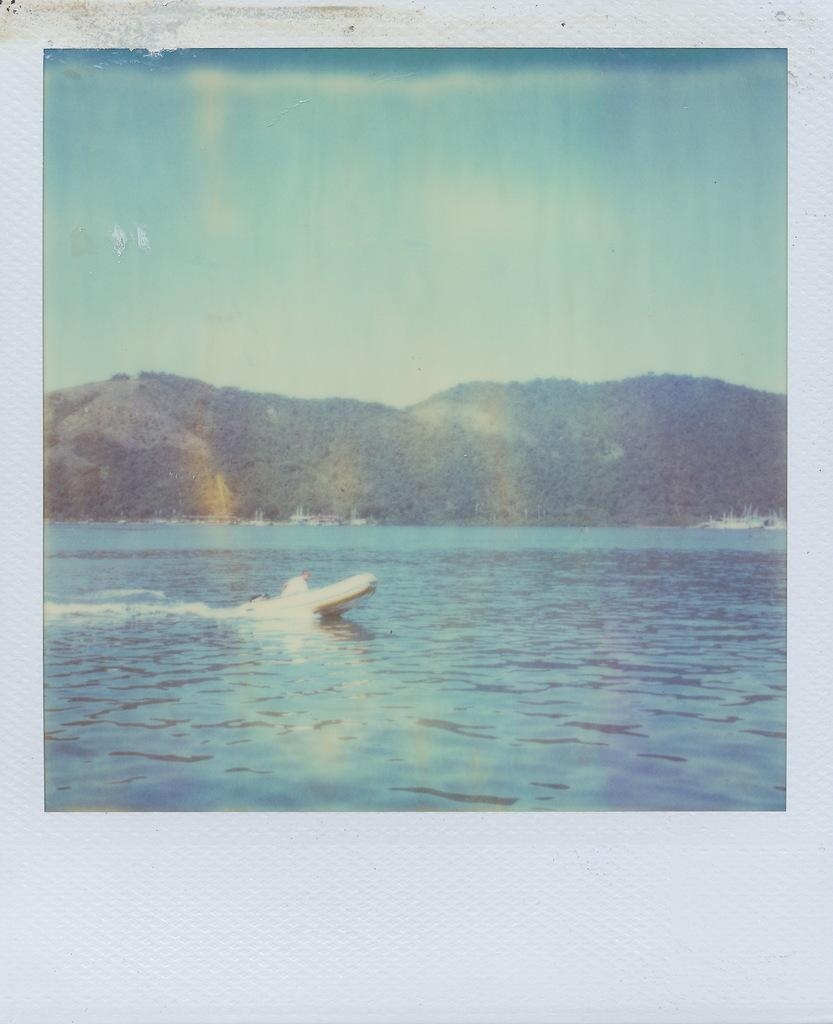What is in the water in the image? There is a boat in the water in the image. What can be seen in the background of the image? There are mountains in the background. What is visible at the top of the image? The sky is visible at the top of the image. What type of bells can be heard ringing in the image? There are no bells present in the image, and therefore no sound can be heard. 